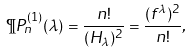Convert formula to latex. <formula><loc_0><loc_0><loc_500><loc_500>\P P _ { n } ^ { ( 1 ) } ( \lambda ) = \frac { n ! } { ( H _ { \lambda } ) ^ { 2 } } = \frac { ( f ^ { \lambda } ) ^ { 2 } } { n ! } ,</formula> 